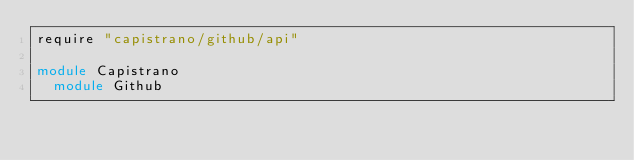Convert code to text. <code><loc_0><loc_0><loc_500><loc_500><_Ruby_>require "capistrano/github/api"

module Capistrano
  module Github</code> 